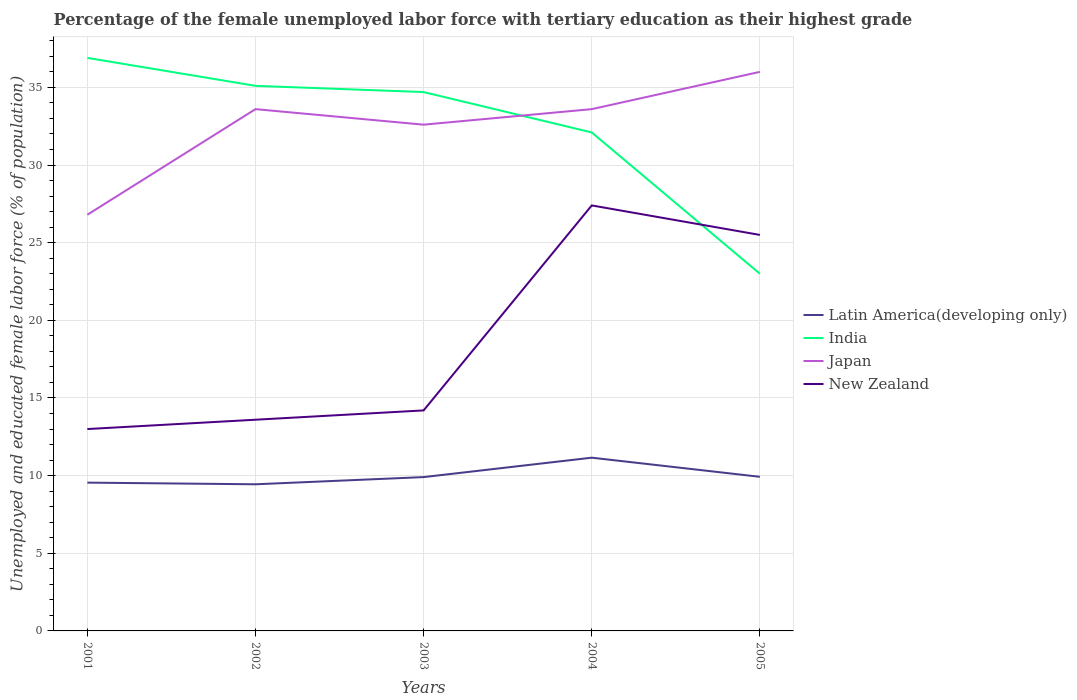Across all years, what is the maximum percentage of the unemployed female labor force with tertiary education in Japan?
Provide a short and direct response. 26.8. What is the total percentage of the unemployed female labor force with tertiary education in Japan in the graph?
Give a very brief answer. -2.4. What is the difference between the highest and the second highest percentage of the unemployed female labor force with tertiary education in Japan?
Make the answer very short. 9.2. Is the percentage of the unemployed female labor force with tertiary education in New Zealand strictly greater than the percentage of the unemployed female labor force with tertiary education in Japan over the years?
Keep it short and to the point. Yes. How many lines are there?
Give a very brief answer. 4. Does the graph contain grids?
Give a very brief answer. Yes. Where does the legend appear in the graph?
Offer a terse response. Center right. How many legend labels are there?
Give a very brief answer. 4. What is the title of the graph?
Provide a succinct answer. Percentage of the female unemployed labor force with tertiary education as their highest grade. What is the label or title of the X-axis?
Offer a very short reply. Years. What is the label or title of the Y-axis?
Your response must be concise. Unemployed and educated female labor force (% of population). What is the Unemployed and educated female labor force (% of population) in Latin America(developing only) in 2001?
Offer a very short reply. 9.55. What is the Unemployed and educated female labor force (% of population) of India in 2001?
Your answer should be very brief. 36.9. What is the Unemployed and educated female labor force (% of population) of Japan in 2001?
Give a very brief answer. 26.8. What is the Unemployed and educated female labor force (% of population) of New Zealand in 2001?
Offer a very short reply. 13. What is the Unemployed and educated female labor force (% of population) in Latin America(developing only) in 2002?
Give a very brief answer. 9.44. What is the Unemployed and educated female labor force (% of population) in India in 2002?
Your answer should be compact. 35.1. What is the Unemployed and educated female labor force (% of population) of Japan in 2002?
Offer a very short reply. 33.6. What is the Unemployed and educated female labor force (% of population) of New Zealand in 2002?
Offer a very short reply. 13.6. What is the Unemployed and educated female labor force (% of population) of Latin America(developing only) in 2003?
Provide a short and direct response. 9.91. What is the Unemployed and educated female labor force (% of population) of India in 2003?
Provide a succinct answer. 34.7. What is the Unemployed and educated female labor force (% of population) of Japan in 2003?
Offer a terse response. 32.6. What is the Unemployed and educated female labor force (% of population) in New Zealand in 2003?
Make the answer very short. 14.2. What is the Unemployed and educated female labor force (% of population) in Latin America(developing only) in 2004?
Ensure brevity in your answer.  11.16. What is the Unemployed and educated female labor force (% of population) of India in 2004?
Make the answer very short. 32.1. What is the Unemployed and educated female labor force (% of population) of Japan in 2004?
Your response must be concise. 33.6. What is the Unemployed and educated female labor force (% of population) of New Zealand in 2004?
Offer a very short reply. 27.4. What is the Unemployed and educated female labor force (% of population) of Latin America(developing only) in 2005?
Make the answer very short. 9.92. What is the Unemployed and educated female labor force (% of population) in Japan in 2005?
Give a very brief answer. 36. Across all years, what is the maximum Unemployed and educated female labor force (% of population) of Latin America(developing only)?
Give a very brief answer. 11.16. Across all years, what is the maximum Unemployed and educated female labor force (% of population) of India?
Provide a succinct answer. 36.9. Across all years, what is the maximum Unemployed and educated female labor force (% of population) in Japan?
Make the answer very short. 36. Across all years, what is the maximum Unemployed and educated female labor force (% of population) of New Zealand?
Ensure brevity in your answer.  27.4. Across all years, what is the minimum Unemployed and educated female labor force (% of population) in Latin America(developing only)?
Make the answer very short. 9.44. Across all years, what is the minimum Unemployed and educated female labor force (% of population) in India?
Your response must be concise. 23. Across all years, what is the minimum Unemployed and educated female labor force (% of population) of Japan?
Give a very brief answer. 26.8. Across all years, what is the minimum Unemployed and educated female labor force (% of population) of New Zealand?
Your answer should be very brief. 13. What is the total Unemployed and educated female labor force (% of population) of Latin America(developing only) in the graph?
Your response must be concise. 49.98. What is the total Unemployed and educated female labor force (% of population) of India in the graph?
Your answer should be compact. 161.8. What is the total Unemployed and educated female labor force (% of population) of Japan in the graph?
Make the answer very short. 162.6. What is the total Unemployed and educated female labor force (% of population) of New Zealand in the graph?
Ensure brevity in your answer.  93.7. What is the difference between the Unemployed and educated female labor force (% of population) in Latin America(developing only) in 2001 and that in 2002?
Provide a short and direct response. 0.11. What is the difference between the Unemployed and educated female labor force (% of population) in India in 2001 and that in 2002?
Provide a succinct answer. 1.8. What is the difference between the Unemployed and educated female labor force (% of population) in Latin America(developing only) in 2001 and that in 2003?
Offer a terse response. -0.36. What is the difference between the Unemployed and educated female labor force (% of population) of New Zealand in 2001 and that in 2003?
Provide a short and direct response. -1.2. What is the difference between the Unemployed and educated female labor force (% of population) of Latin America(developing only) in 2001 and that in 2004?
Ensure brevity in your answer.  -1.61. What is the difference between the Unemployed and educated female labor force (% of population) of Japan in 2001 and that in 2004?
Your answer should be very brief. -6.8. What is the difference between the Unemployed and educated female labor force (% of population) in New Zealand in 2001 and that in 2004?
Make the answer very short. -14.4. What is the difference between the Unemployed and educated female labor force (% of population) in Latin America(developing only) in 2001 and that in 2005?
Offer a very short reply. -0.38. What is the difference between the Unemployed and educated female labor force (% of population) in India in 2001 and that in 2005?
Provide a succinct answer. 13.9. What is the difference between the Unemployed and educated female labor force (% of population) of New Zealand in 2001 and that in 2005?
Provide a short and direct response. -12.5. What is the difference between the Unemployed and educated female labor force (% of population) in Latin America(developing only) in 2002 and that in 2003?
Give a very brief answer. -0.46. What is the difference between the Unemployed and educated female labor force (% of population) in India in 2002 and that in 2003?
Your response must be concise. 0.4. What is the difference between the Unemployed and educated female labor force (% of population) of Japan in 2002 and that in 2003?
Give a very brief answer. 1. What is the difference between the Unemployed and educated female labor force (% of population) of New Zealand in 2002 and that in 2003?
Your answer should be very brief. -0.6. What is the difference between the Unemployed and educated female labor force (% of population) of Latin America(developing only) in 2002 and that in 2004?
Keep it short and to the point. -1.71. What is the difference between the Unemployed and educated female labor force (% of population) of India in 2002 and that in 2004?
Keep it short and to the point. 3. What is the difference between the Unemployed and educated female labor force (% of population) in Japan in 2002 and that in 2004?
Provide a short and direct response. 0. What is the difference between the Unemployed and educated female labor force (% of population) in Latin America(developing only) in 2002 and that in 2005?
Give a very brief answer. -0.48. What is the difference between the Unemployed and educated female labor force (% of population) of Japan in 2002 and that in 2005?
Offer a terse response. -2.4. What is the difference between the Unemployed and educated female labor force (% of population) of New Zealand in 2002 and that in 2005?
Keep it short and to the point. -11.9. What is the difference between the Unemployed and educated female labor force (% of population) in Latin America(developing only) in 2003 and that in 2004?
Provide a succinct answer. -1.25. What is the difference between the Unemployed and educated female labor force (% of population) in Latin America(developing only) in 2003 and that in 2005?
Your answer should be very brief. -0.02. What is the difference between the Unemployed and educated female labor force (% of population) in Japan in 2003 and that in 2005?
Provide a succinct answer. -3.4. What is the difference between the Unemployed and educated female labor force (% of population) of Latin America(developing only) in 2004 and that in 2005?
Keep it short and to the point. 1.23. What is the difference between the Unemployed and educated female labor force (% of population) of India in 2004 and that in 2005?
Offer a very short reply. 9.1. What is the difference between the Unemployed and educated female labor force (% of population) in New Zealand in 2004 and that in 2005?
Ensure brevity in your answer.  1.9. What is the difference between the Unemployed and educated female labor force (% of population) of Latin America(developing only) in 2001 and the Unemployed and educated female labor force (% of population) of India in 2002?
Your answer should be compact. -25.55. What is the difference between the Unemployed and educated female labor force (% of population) in Latin America(developing only) in 2001 and the Unemployed and educated female labor force (% of population) in Japan in 2002?
Make the answer very short. -24.05. What is the difference between the Unemployed and educated female labor force (% of population) in Latin America(developing only) in 2001 and the Unemployed and educated female labor force (% of population) in New Zealand in 2002?
Your response must be concise. -4.05. What is the difference between the Unemployed and educated female labor force (% of population) in India in 2001 and the Unemployed and educated female labor force (% of population) in Japan in 2002?
Offer a terse response. 3.3. What is the difference between the Unemployed and educated female labor force (% of population) of India in 2001 and the Unemployed and educated female labor force (% of population) of New Zealand in 2002?
Provide a short and direct response. 23.3. What is the difference between the Unemployed and educated female labor force (% of population) in Japan in 2001 and the Unemployed and educated female labor force (% of population) in New Zealand in 2002?
Provide a short and direct response. 13.2. What is the difference between the Unemployed and educated female labor force (% of population) in Latin America(developing only) in 2001 and the Unemployed and educated female labor force (% of population) in India in 2003?
Give a very brief answer. -25.15. What is the difference between the Unemployed and educated female labor force (% of population) in Latin America(developing only) in 2001 and the Unemployed and educated female labor force (% of population) in Japan in 2003?
Offer a very short reply. -23.05. What is the difference between the Unemployed and educated female labor force (% of population) of Latin America(developing only) in 2001 and the Unemployed and educated female labor force (% of population) of New Zealand in 2003?
Your response must be concise. -4.65. What is the difference between the Unemployed and educated female labor force (% of population) of India in 2001 and the Unemployed and educated female labor force (% of population) of New Zealand in 2003?
Your answer should be compact. 22.7. What is the difference between the Unemployed and educated female labor force (% of population) of Latin America(developing only) in 2001 and the Unemployed and educated female labor force (% of population) of India in 2004?
Offer a terse response. -22.55. What is the difference between the Unemployed and educated female labor force (% of population) in Latin America(developing only) in 2001 and the Unemployed and educated female labor force (% of population) in Japan in 2004?
Your response must be concise. -24.05. What is the difference between the Unemployed and educated female labor force (% of population) in Latin America(developing only) in 2001 and the Unemployed and educated female labor force (% of population) in New Zealand in 2004?
Your response must be concise. -17.85. What is the difference between the Unemployed and educated female labor force (% of population) in India in 2001 and the Unemployed and educated female labor force (% of population) in Japan in 2004?
Ensure brevity in your answer.  3.3. What is the difference between the Unemployed and educated female labor force (% of population) in India in 2001 and the Unemployed and educated female labor force (% of population) in New Zealand in 2004?
Provide a succinct answer. 9.5. What is the difference between the Unemployed and educated female labor force (% of population) in Latin America(developing only) in 2001 and the Unemployed and educated female labor force (% of population) in India in 2005?
Offer a terse response. -13.45. What is the difference between the Unemployed and educated female labor force (% of population) in Latin America(developing only) in 2001 and the Unemployed and educated female labor force (% of population) in Japan in 2005?
Make the answer very short. -26.45. What is the difference between the Unemployed and educated female labor force (% of population) in Latin America(developing only) in 2001 and the Unemployed and educated female labor force (% of population) in New Zealand in 2005?
Provide a short and direct response. -15.95. What is the difference between the Unemployed and educated female labor force (% of population) in India in 2001 and the Unemployed and educated female labor force (% of population) in New Zealand in 2005?
Offer a very short reply. 11.4. What is the difference between the Unemployed and educated female labor force (% of population) in Latin America(developing only) in 2002 and the Unemployed and educated female labor force (% of population) in India in 2003?
Your response must be concise. -25.26. What is the difference between the Unemployed and educated female labor force (% of population) in Latin America(developing only) in 2002 and the Unemployed and educated female labor force (% of population) in Japan in 2003?
Provide a short and direct response. -23.16. What is the difference between the Unemployed and educated female labor force (% of population) in Latin America(developing only) in 2002 and the Unemployed and educated female labor force (% of population) in New Zealand in 2003?
Offer a terse response. -4.76. What is the difference between the Unemployed and educated female labor force (% of population) of India in 2002 and the Unemployed and educated female labor force (% of population) of Japan in 2003?
Give a very brief answer. 2.5. What is the difference between the Unemployed and educated female labor force (% of population) in India in 2002 and the Unemployed and educated female labor force (% of population) in New Zealand in 2003?
Keep it short and to the point. 20.9. What is the difference between the Unemployed and educated female labor force (% of population) in Latin America(developing only) in 2002 and the Unemployed and educated female labor force (% of population) in India in 2004?
Make the answer very short. -22.66. What is the difference between the Unemployed and educated female labor force (% of population) of Latin America(developing only) in 2002 and the Unemployed and educated female labor force (% of population) of Japan in 2004?
Offer a very short reply. -24.16. What is the difference between the Unemployed and educated female labor force (% of population) of Latin America(developing only) in 2002 and the Unemployed and educated female labor force (% of population) of New Zealand in 2004?
Your answer should be compact. -17.96. What is the difference between the Unemployed and educated female labor force (% of population) of Latin America(developing only) in 2002 and the Unemployed and educated female labor force (% of population) of India in 2005?
Offer a terse response. -13.56. What is the difference between the Unemployed and educated female labor force (% of population) of Latin America(developing only) in 2002 and the Unemployed and educated female labor force (% of population) of Japan in 2005?
Offer a terse response. -26.56. What is the difference between the Unemployed and educated female labor force (% of population) of Latin America(developing only) in 2002 and the Unemployed and educated female labor force (% of population) of New Zealand in 2005?
Offer a very short reply. -16.06. What is the difference between the Unemployed and educated female labor force (% of population) of India in 2002 and the Unemployed and educated female labor force (% of population) of Japan in 2005?
Make the answer very short. -0.9. What is the difference between the Unemployed and educated female labor force (% of population) of Latin America(developing only) in 2003 and the Unemployed and educated female labor force (% of population) of India in 2004?
Your response must be concise. -22.19. What is the difference between the Unemployed and educated female labor force (% of population) in Latin America(developing only) in 2003 and the Unemployed and educated female labor force (% of population) in Japan in 2004?
Keep it short and to the point. -23.69. What is the difference between the Unemployed and educated female labor force (% of population) of Latin America(developing only) in 2003 and the Unemployed and educated female labor force (% of population) of New Zealand in 2004?
Your answer should be very brief. -17.49. What is the difference between the Unemployed and educated female labor force (% of population) in India in 2003 and the Unemployed and educated female labor force (% of population) in Japan in 2004?
Offer a very short reply. 1.1. What is the difference between the Unemployed and educated female labor force (% of population) in Japan in 2003 and the Unemployed and educated female labor force (% of population) in New Zealand in 2004?
Make the answer very short. 5.2. What is the difference between the Unemployed and educated female labor force (% of population) in Latin America(developing only) in 2003 and the Unemployed and educated female labor force (% of population) in India in 2005?
Keep it short and to the point. -13.09. What is the difference between the Unemployed and educated female labor force (% of population) of Latin America(developing only) in 2003 and the Unemployed and educated female labor force (% of population) of Japan in 2005?
Make the answer very short. -26.09. What is the difference between the Unemployed and educated female labor force (% of population) of Latin America(developing only) in 2003 and the Unemployed and educated female labor force (% of population) of New Zealand in 2005?
Offer a very short reply. -15.59. What is the difference between the Unemployed and educated female labor force (% of population) of Latin America(developing only) in 2004 and the Unemployed and educated female labor force (% of population) of India in 2005?
Keep it short and to the point. -11.84. What is the difference between the Unemployed and educated female labor force (% of population) in Latin America(developing only) in 2004 and the Unemployed and educated female labor force (% of population) in Japan in 2005?
Offer a very short reply. -24.84. What is the difference between the Unemployed and educated female labor force (% of population) in Latin America(developing only) in 2004 and the Unemployed and educated female labor force (% of population) in New Zealand in 2005?
Keep it short and to the point. -14.34. What is the difference between the Unemployed and educated female labor force (% of population) of India in 2004 and the Unemployed and educated female labor force (% of population) of Japan in 2005?
Offer a very short reply. -3.9. What is the difference between the Unemployed and educated female labor force (% of population) of Japan in 2004 and the Unemployed and educated female labor force (% of population) of New Zealand in 2005?
Your answer should be compact. 8.1. What is the average Unemployed and educated female labor force (% of population) of Latin America(developing only) per year?
Keep it short and to the point. 10. What is the average Unemployed and educated female labor force (% of population) of India per year?
Provide a succinct answer. 32.36. What is the average Unemployed and educated female labor force (% of population) of Japan per year?
Provide a short and direct response. 32.52. What is the average Unemployed and educated female labor force (% of population) in New Zealand per year?
Provide a short and direct response. 18.74. In the year 2001, what is the difference between the Unemployed and educated female labor force (% of population) in Latin America(developing only) and Unemployed and educated female labor force (% of population) in India?
Your answer should be very brief. -27.35. In the year 2001, what is the difference between the Unemployed and educated female labor force (% of population) of Latin America(developing only) and Unemployed and educated female labor force (% of population) of Japan?
Offer a terse response. -17.25. In the year 2001, what is the difference between the Unemployed and educated female labor force (% of population) of Latin America(developing only) and Unemployed and educated female labor force (% of population) of New Zealand?
Your response must be concise. -3.45. In the year 2001, what is the difference between the Unemployed and educated female labor force (% of population) in India and Unemployed and educated female labor force (% of population) in New Zealand?
Offer a terse response. 23.9. In the year 2002, what is the difference between the Unemployed and educated female labor force (% of population) in Latin America(developing only) and Unemployed and educated female labor force (% of population) in India?
Provide a short and direct response. -25.66. In the year 2002, what is the difference between the Unemployed and educated female labor force (% of population) in Latin America(developing only) and Unemployed and educated female labor force (% of population) in Japan?
Offer a terse response. -24.16. In the year 2002, what is the difference between the Unemployed and educated female labor force (% of population) in Latin America(developing only) and Unemployed and educated female labor force (% of population) in New Zealand?
Your answer should be compact. -4.16. In the year 2003, what is the difference between the Unemployed and educated female labor force (% of population) in Latin America(developing only) and Unemployed and educated female labor force (% of population) in India?
Your answer should be very brief. -24.79. In the year 2003, what is the difference between the Unemployed and educated female labor force (% of population) in Latin America(developing only) and Unemployed and educated female labor force (% of population) in Japan?
Ensure brevity in your answer.  -22.69. In the year 2003, what is the difference between the Unemployed and educated female labor force (% of population) in Latin America(developing only) and Unemployed and educated female labor force (% of population) in New Zealand?
Ensure brevity in your answer.  -4.29. In the year 2003, what is the difference between the Unemployed and educated female labor force (% of population) in India and Unemployed and educated female labor force (% of population) in Japan?
Offer a very short reply. 2.1. In the year 2003, what is the difference between the Unemployed and educated female labor force (% of population) of Japan and Unemployed and educated female labor force (% of population) of New Zealand?
Your answer should be very brief. 18.4. In the year 2004, what is the difference between the Unemployed and educated female labor force (% of population) in Latin America(developing only) and Unemployed and educated female labor force (% of population) in India?
Ensure brevity in your answer.  -20.94. In the year 2004, what is the difference between the Unemployed and educated female labor force (% of population) in Latin America(developing only) and Unemployed and educated female labor force (% of population) in Japan?
Your answer should be compact. -22.44. In the year 2004, what is the difference between the Unemployed and educated female labor force (% of population) of Latin America(developing only) and Unemployed and educated female labor force (% of population) of New Zealand?
Provide a short and direct response. -16.24. In the year 2004, what is the difference between the Unemployed and educated female labor force (% of population) of India and Unemployed and educated female labor force (% of population) of Japan?
Provide a succinct answer. -1.5. In the year 2004, what is the difference between the Unemployed and educated female labor force (% of population) of India and Unemployed and educated female labor force (% of population) of New Zealand?
Ensure brevity in your answer.  4.7. In the year 2005, what is the difference between the Unemployed and educated female labor force (% of population) of Latin America(developing only) and Unemployed and educated female labor force (% of population) of India?
Give a very brief answer. -13.08. In the year 2005, what is the difference between the Unemployed and educated female labor force (% of population) in Latin America(developing only) and Unemployed and educated female labor force (% of population) in Japan?
Offer a terse response. -26.08. In the year 2005, what is the difference between the Unemployed and educated female labor force (% of population) in Latin America(developing only) and Unemployed and educated female labor force (% of population) in New Zealand?
Your answer should be very brief. -15.58. In the year 2005, what is the difference between the Unemployed and educated female labor force (% of population) of India and Unemployed and educated female labor force (% of population) of Japan?
Offer a very short reply. -13. In the year 2005, what is the difference between the Unemployed and educated female labor force (% of population) of India and Unemployed and educated female labor force (% of population) of New Zealand?
Keep it short and to the point. -2.5. In the year 2005, what is the difference between the Unemployed and educated female labor force (% of population) in Japan and Unemployed and educated female labor force (% of population) in New Zealand?
Your answer should be compact. 10.5. What is the ratio of the Unemployed and educated female labor force (% of population) in Latin America(developing only) in 2001 to that in 2002?
Give a very brief answer. 1.01. What is the ratio of the Unemployed and educated female labor force (% of population) of India in 2001 to that in 2002?
Make the answer very short. 1.05. What is the ratio of the Unemployed and educated female labor force (% of population) in Japan in 2001 to that in 2002?
Offer a very short reply. 0.8. What is the ratio of the Unemployed and educated female labor force (% of population) of New Zealand in 2001 to that in 2002?
Your answer should be very brief. 0.96. What is the ratio of the Unemployed and educated female labor force (% of population) of Latin America(developing only) in 2001 to that in 2003?
Offer a terse response. 0.96. What is the ratio of the Unemployed and educated female labor force (% of population) of India in 2001 to that in 2003?
Offer a very short reply. 1.06. What is the ratio of the Unemployed and educated female labor force (% of population) in Japan in 2001 to that in 2003?
Give a very brief answer. 0.82. What is the ratio of the Unemployed and educated female labor force (% of population) of New Zealand in 2001 to that in 2003?
Make the answer very short. 0.92. What is the ratio of the Unemployed and educated female labor force (% of population) of Latin America(developing only) in 2001 to that in 2004?
Keep it short and to the point. 0.86. What is the ratio of the Unemployed and educated female labor force (% of population) in India in 2001 to that in 2004?
Offer a terse response. 1.15. What is the ratio of the Unemployed and educated female labor force (% of population) of Japan in 2001 to that in 2004?
Your answer should be very brief. 0.8. What is the ratio of the Unemployed and educated female labor force (% of population) of New Zealand in 2001 to that in 2004?
Keep it short and to the point. 0.47. What is the ratio of the Unemployed and educated female labor force (% of population) in Latin America(developing only) in 2001 to that in 2005?
Provide a short and direct response. 0.96. What is the ratio of the Unemployed and educated female labor force (% of population) of India in 2001 to that in 2005?
Offer a terse response. 1.6. What is the ratio of the Unemployed and educated female labor force (% of population) in Japan in 2001 to that in 2005?
Your answer should be very brief. 0.74. What is the ratio of the Unemployed and educated female labor force (% of population) of New Zealand in 2001 to that in 2005?
Provide a succinct answer. 0.51. What is the ratio of the Unemployed and educated female labor force (% of population) of Latin America(developing only) in 2002 to that in 2003?
Offer a terse response. 0.95. What is the ratio of the Unemployed and educated female labor force (% of population) in India in 2002 to that in 2003?
Make the answer very short. 1.01. What is the ratio of the Unemployed and educated female labor force (% of population) of Japan in 2002 to that in 2003?
Keep it short and to the point. 1.03. What is the ratio of the Unemployed and educated female labor force (% of population) in New Zealand in 2002 to that in 2003?
Provide a short and direct response. 0.96. What is the ratio of the Unemployed and educated female labor force (% of population) in Latin America(developing only) in 2002 to that in 2004?
Make the answer very short. 0.85. What is the ratio of the Unemployed and educated female labor force (% of population) of India in 2002 to that in 2004?
Make the answer very short. 1.09. What is the ratio of the Unemployed and educated female labor force (% of population) of Japan in 2002 to that in 2004?
Your answer should be very brief. 1. What is the ratio of the Unemployed and educated female labor force (% of population) of New Zealand in 2002 to that in 2004?
Provide a short and direct response. 0.5. What is the ratio of the Unemployed and educated female labor force (% of population) of Latin America(developing only) in 2002 to that in 2005?
Your response must be concise. 0.95. What is the ratio of the Unemployed and educated female labor force (% of population) of India in 2002 to that in 2005?
Offer a very short reply. 1.53. What is the ratio of the Unemployed and educated female labor force (% of population) in Japan in 2002 to that in 2005?
Make the answer very short. 0.93. What is the ratio of the Unemployed and educated female labor force (% of population) in New Zealand in 2002 to that in 2005?
Provide a short and direct response. 0.53. What is the ratio of the Unemployed and educated female labor force (% of population) of Latin America(developing only) in 2003 to that in 2004?
Your answer should be very brief. 0.89. What is the ratio of the Unemployed and educated female labor force (% of population) of India in 2003 to that in 2004?
Your answer should be very brief. 1.08. What is the ratio of the Unemployed and educated female labor force (% of population) in Japan in 2003 to that in 2004?
Provide a succinct answer. 0.97. What is the ratio of the Unemployed and educated female labor force (% of population) in New Zealand in 2003 to that in 2004?
Make the answer very short. 0.52. What is the ratio of the Unemployed and educated female labor force (% of population) of Latin America(developing only) in 2003 to that in 2005?
Make the answer very short. 1. What is the ratio of the Unemployed and educated female labor force (% of population) of India in 2003 to that in 2005?
Keep it short and to the point. 1.51. What is the ratio of the Unemployed and educated female labor force (% of population) in Japan in 2003 to that in 2005?
Make the answer very short. 0.91. What is the ratio of the Unemployed and educated female labor force (% of population) in New Zealand in 2003 to that in 2005?
Offer a terse response. 0.56. What is the ratio of the Unemployed and educated female labor force (% of population) of Latin America(developing only) in 2004 to that in 2005?
Make the answer very short. 1.12. What is the ratio of the Unemployed and educated female labor force (% of population) in India in 2004 to that in 2005?
Keep it short and to the point. 1.4. What is the ratio of the Unemployed and educated female labor force (% of population) in Japan in 2004 to that in 2005?
Offer a terse response. 0.93. What is the ratio of the Unemployed and educated female labor force (% of population) in New Zealand in 2004 to that in 2005?
Provide a short and direct response. 1.07. What is the difference between the highest and the second highest Unemployed and educated female labor force (% of population) in Latin America(developing only)?
Keep it short and to the point. 1.23. What is the difference between the highest and the second highest Unemployed and educated female labor force (% of population) in Japan?
Your answer should be compact. 2.4. What is the difference between the highest and the second highest Unemployed and educated female labor force (% of population) of New Zealand?
Ensure brevity in your answer.  1.9. What is the difference between the highest and the lowest Unemployed and educated female labor force (% of population) of Latin America(developing only)?
Make the answer very short. 1.71. What is the difference between the highest and the lowest Unemployed and educated female labor force (% of population) of India?
Your answer should be compact. 13.9. What is the difference between the highest and the lowest Unemployed and educated female labor force (% of population) of New Zealand?
Give a very brief answer. 14.4. 